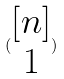<formula> <loc_0><loc_0><loc_500><loc_500>( \begin{matrix} [ n ] \\ 1 \end{matrix} )</formula> 